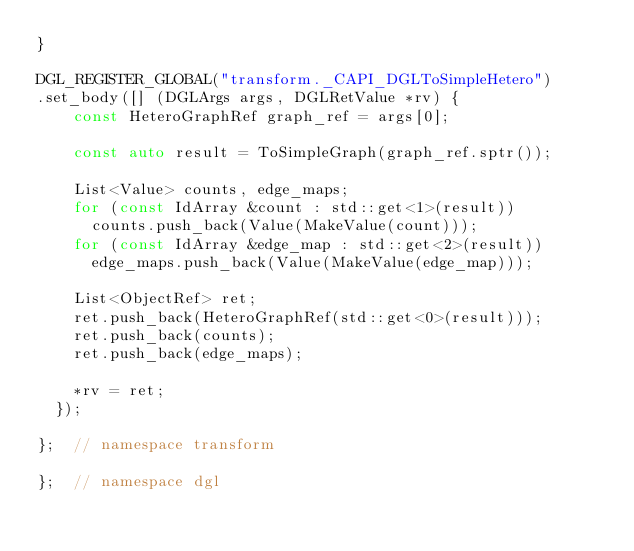<code> <loc_0><loc_0><loc_500><loc_500><_C++_>}

DGL_REGISTER_GLOBAL("transform._CAPI_DGLToSimpleHetero")
.set_body([] (DGLArgs args, DGLRetValue *rv) {
    const HeteroGraphRef graph_ref = args[0];

    const auto result = ToSimpleGraph(graph_ref.sptr());

    List<Value> counts, edge_maps;
    for (const IdArray &count : std::get<1>(result))
      counts.push_back(Value(MakeValue(count)));
    for (const IdArray &edge_map : std::get<2>(result))
      edge_maps.push_back(Value(MakeValue(edge_map)));

    List<ObjectRef> ret;
    ret.push_back(HeteroGraphRef(std::get<0>(result)));
    ret.push_back(counts);
    ret.push_back(edge_maps);

    *rv = ret;
  });

};  // namespace transform

};  // namespace dgl
</code> 